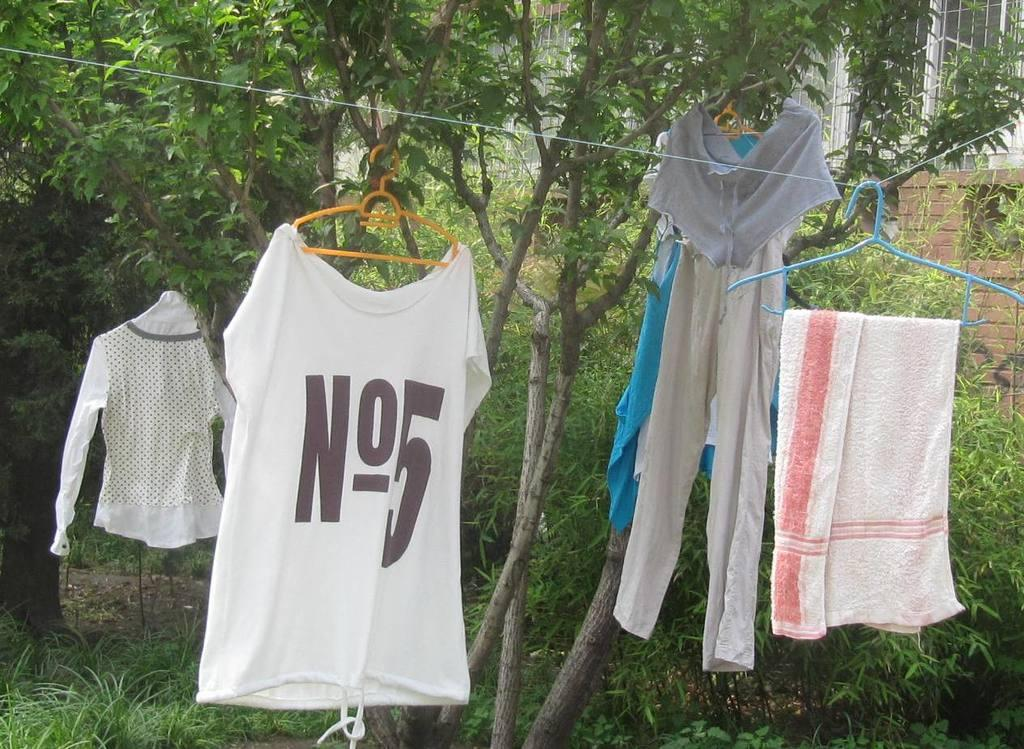<image>
Summarize the visual content of the image. A group of clothes hanging on a clothes line with one shirt saying N05 